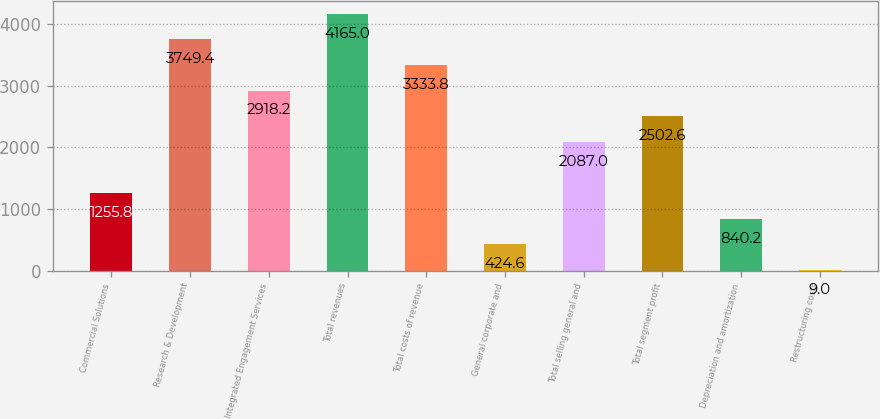Convert chart to OTSL. <chart><loc_0><loc_0><loc_500><loc_500><bar_chart><fcel>Commercial Solutions<fcel>Research & Development<fcel>Integrated Engagement Services<fcel>Total revenues<fcel>Total costs of revenue<fcel>General corporate and<fcel>Total selling general and<fcel>Total segment profit<fcel>Depreciation and amortization<fcel>Restructuring costs<nl><fcel>1255.8<fcel>3749.4<fcel>2918.2<fcel>4165<fcel>3333.8<fcel>424.6<fcel>2087<fcel>2502.6<fcel>840.2<fcel>9<nl></chart> 